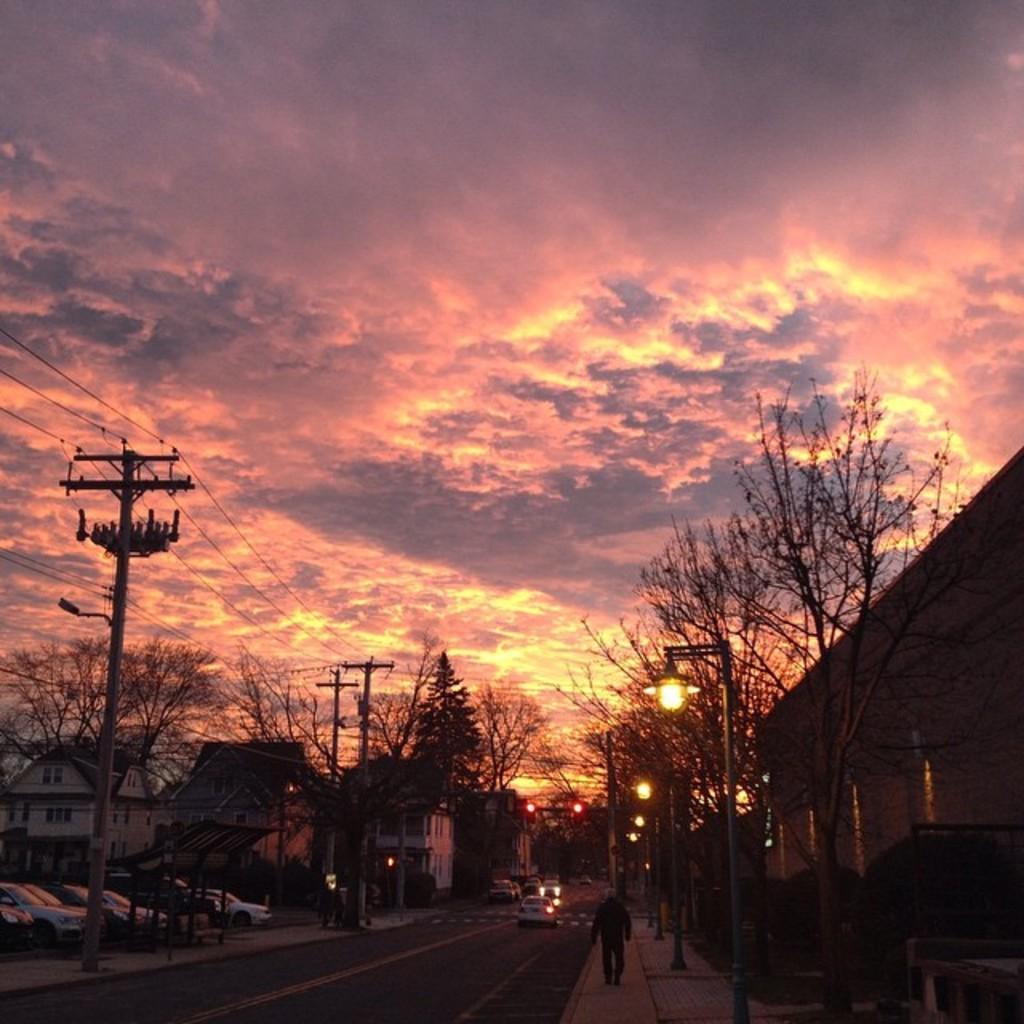Could you give a brief overview of what you see in this image? At the top of the image we can see sky with clouds, trees, electric poles and electric cables. At the bottom of the image we can see motor vehicles, persons, road, buildings, street poles and street lights. 